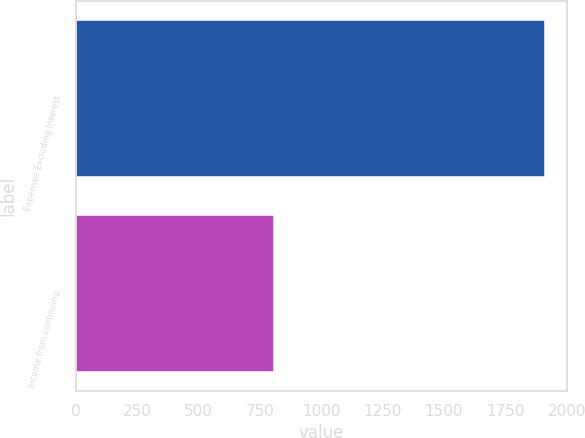Convert chart to OTSL. <chart><loc_0><loc_0><loc_500><loc_500><bar_chart><fcel>Expenses Excluding Interest<fcel>Income from continuing<nl><fcel>1906<fcel>804<nl></chart> 